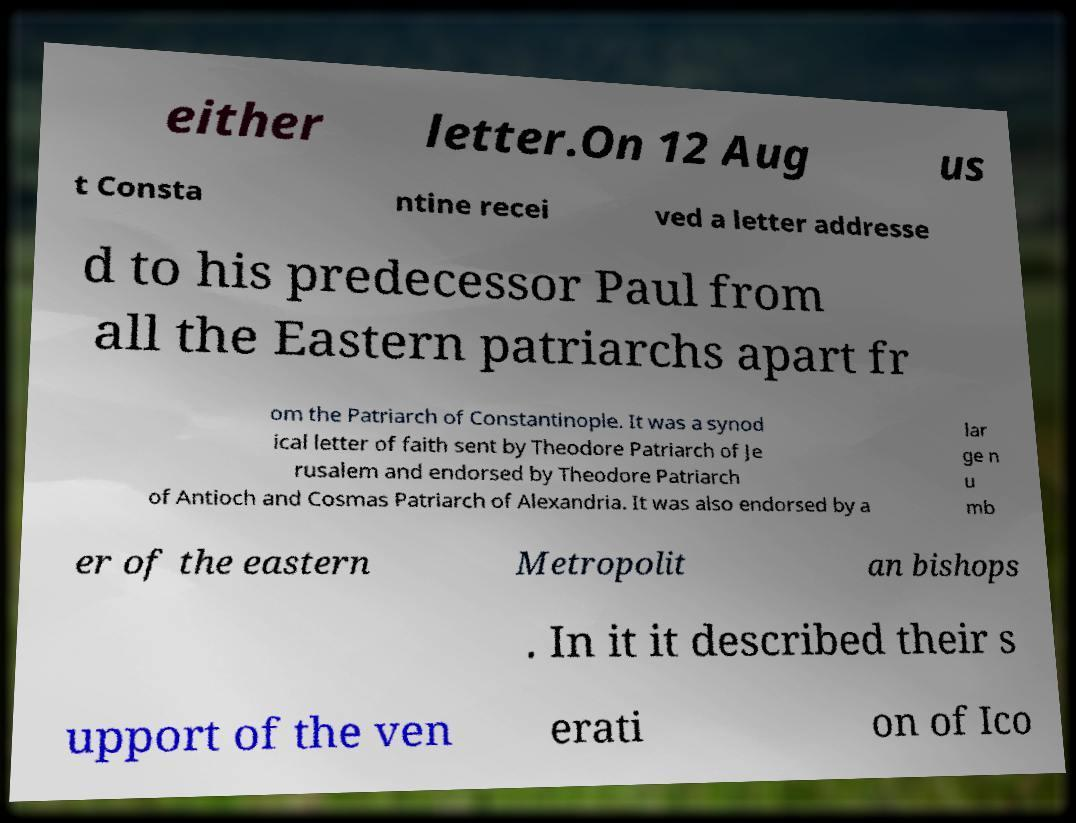Could you assist in decoding the text presented in this image and type it out clearly? either letter.On 12 Aug us t Consta ntine recei ved a letter addresse d to his predecessor Paul from all the Eastern patriarchs apart fr om the Patriarch of Constantinople. It was a synod ical letter of faith sent by Theodore Patriarch of Je rusalem and endorsed by Theodore Patriarch of Antioch and Cosmas Patriarch of Alexandria. It was also endorsed by a lar ge n u mb er of the eastern Metropolit an bishops . In it it described their s upport of the ven erati on of Ico 